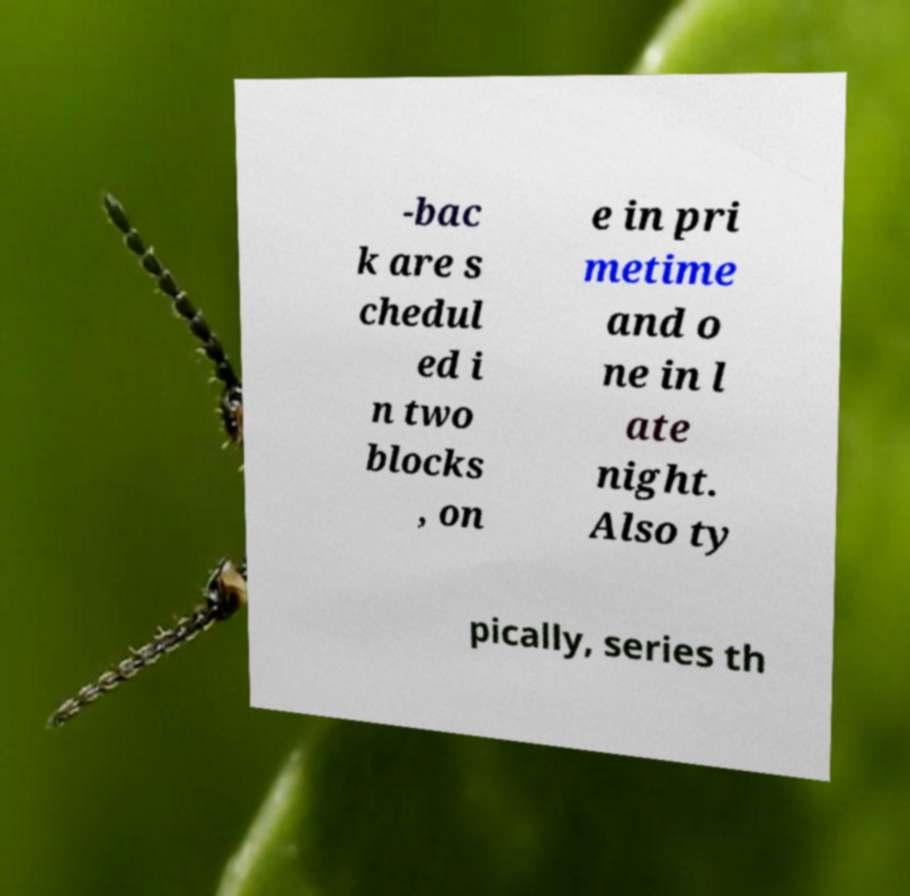I need the written content from this picture converted into text. Can you do that? -bac k are s chedul ed i n two blocks , on e in pri metime and o ne in l ate night. Also ty pically, series th 